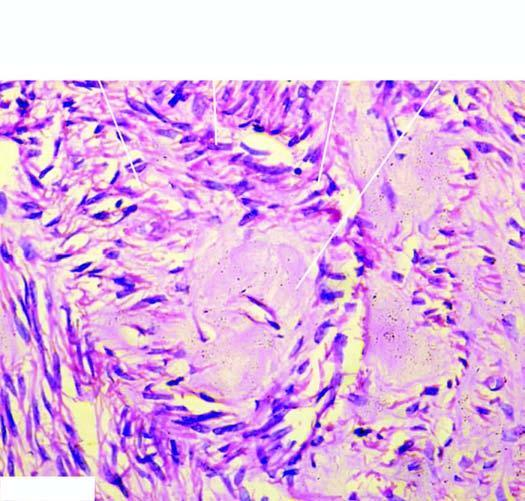what do the centres of whorls of smooth muscle and connective tissue show?
Answer the question using a single word or phrase. Pink homogeneous hyaline material (connective hyaline) 